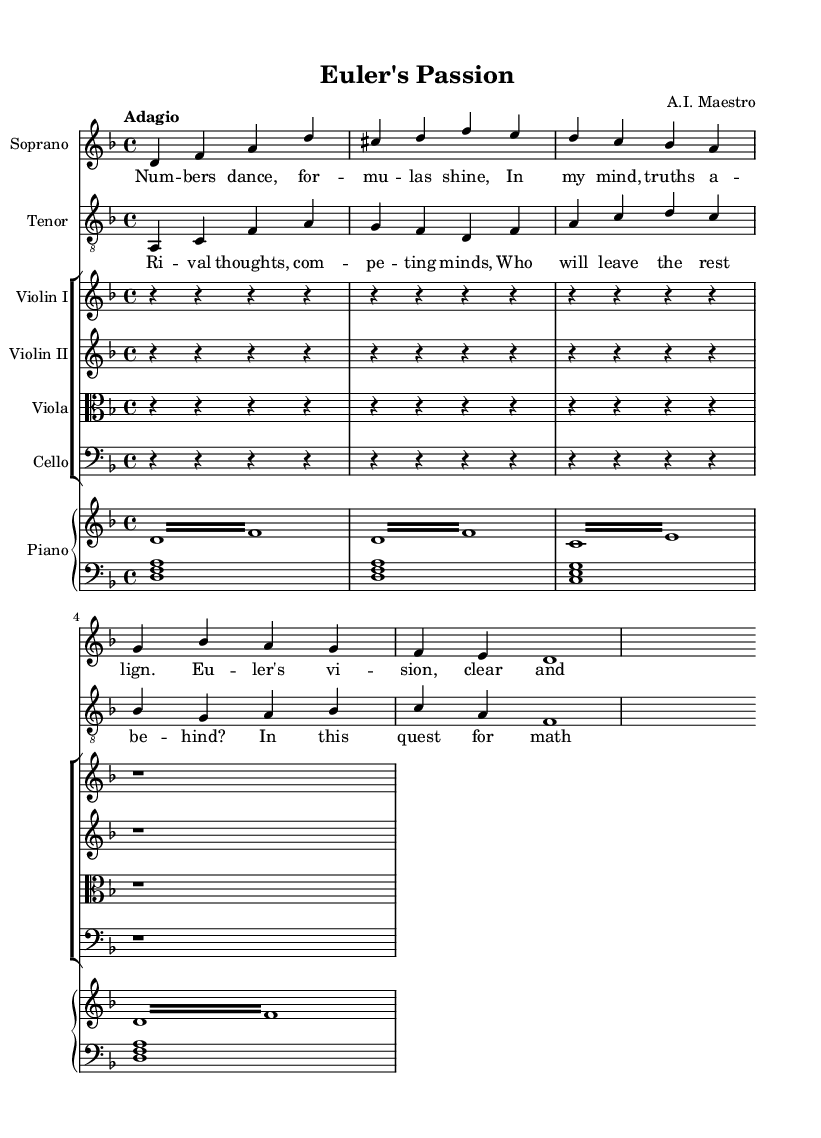What is the key signature of this music? The key signature is indicated at the beginning of the score. The presence of one flat indicates it is in the key of D minor.
Answer: D minor What is the time signature of this music? The time signature is located at the beginning of the score, represented as "4/4," which indicates four beats per measure.
Answer: 4/4 What is the tempo marking for this piece? The tempo marking is found at the start of the music, described as "Adagio," which implies a slow tempo.
Answer: Adagio How many measures are there in the soprano line? The number of measures can be counted in the soprano part where there are a total of four measures shown.
Answer: 4 What is the total number of staves used in this score? The total number of staves is counted across the whole score, including the soprano, tenor, string instruments, and piano, amounting to seven staves in total.
Answer: 7 What type of opera does this music represent based on its theme? The theme focuses on a famous mathematician, which leads to categorizing this as a dramatic opera about mathematicians; therefore, the opera is a dramatic exploration.
Answer: Dramatic opera What role does the piano play in this score? The piano serves both as a harmonic support and rhythmic element, providing accompaniment to the vocal lines through a right-hand melody and left-hand chords.
Answer: Accompaniment 